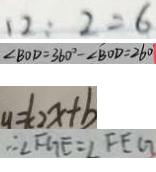Convert formula to latex. <formula><loc_0><loc_0><loc_500><loc_500>1 2 : 2 = 6 
 \angle B O D = 3 6 0 ^ { \circ } - \angle B O D = 2 6 0 
 y = k _ { 2 } x + b 
 \therefore \angle F G E = \angle F E G</formula> 